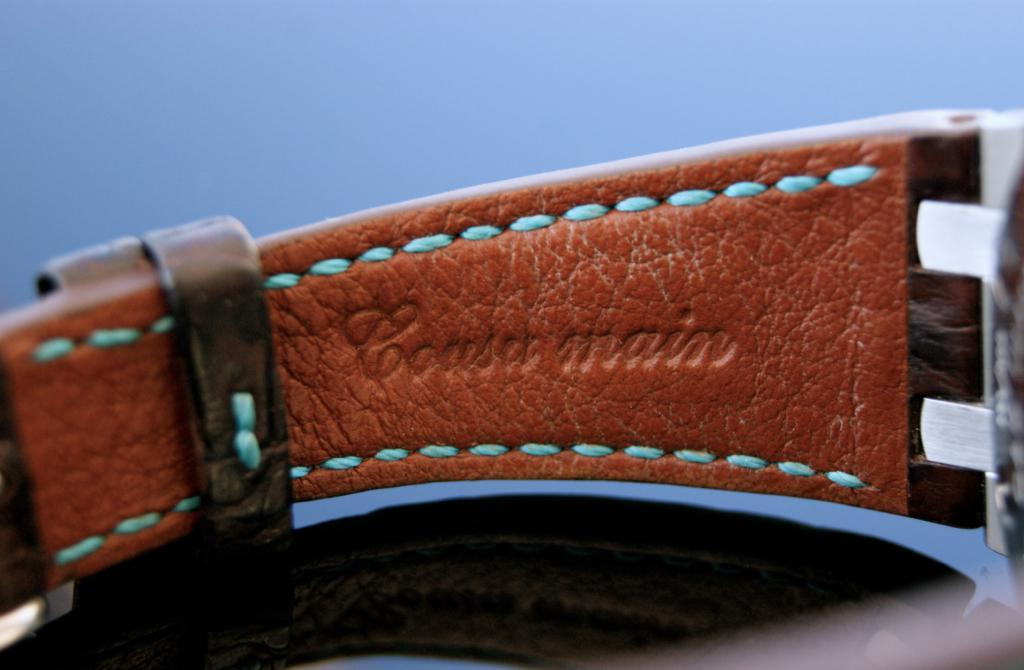<image>
Present a compact description of the photo's key features. Coasa main wrote on a type of belt 